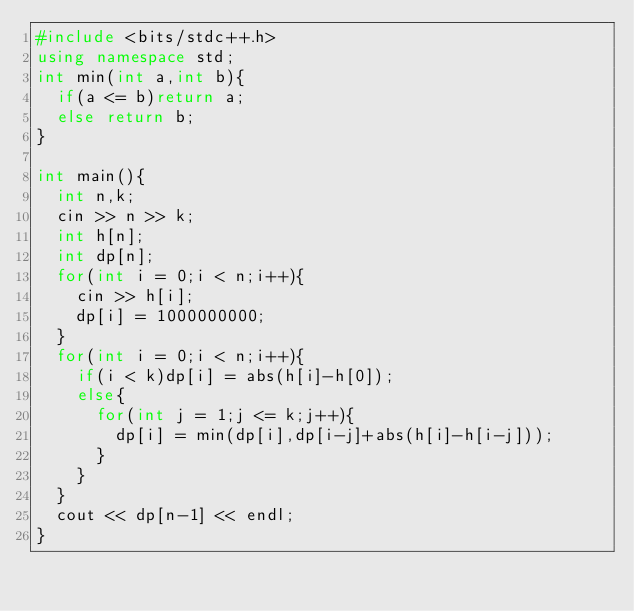<code> <loc_0><loc_0><loc_500><loc_500><_C++_>#include <bits/stdc++.h>
using namespace std;
int min(int a,int b){
  if(a <= b)return a;
  else return b;
}

int main(){
  int n,k;
  cin >> n >> k;
  int h[n];
  int dp[n];
  for(int i = 0;i < n;i++){
    cin >> h[i];
    dp[i] = 1000000000;
  }
  for(int i = 0;i < n;i++){
    if(i < k)dp[i] = abs(h[i]-h[0]);
    else{
      for(int j = 1;j <= k;j++){
        dp[i] = min(dp[i],dp[i-j]+abs(h[i]-h[i-j]));
      }
    }
  }
  cout << dp[n-1] << endl;
}</code> 